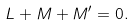<formula> <loc_0><loc_0><loc_500><loc_500>L + M + M ^ { \prime } = 0 .</formula> 